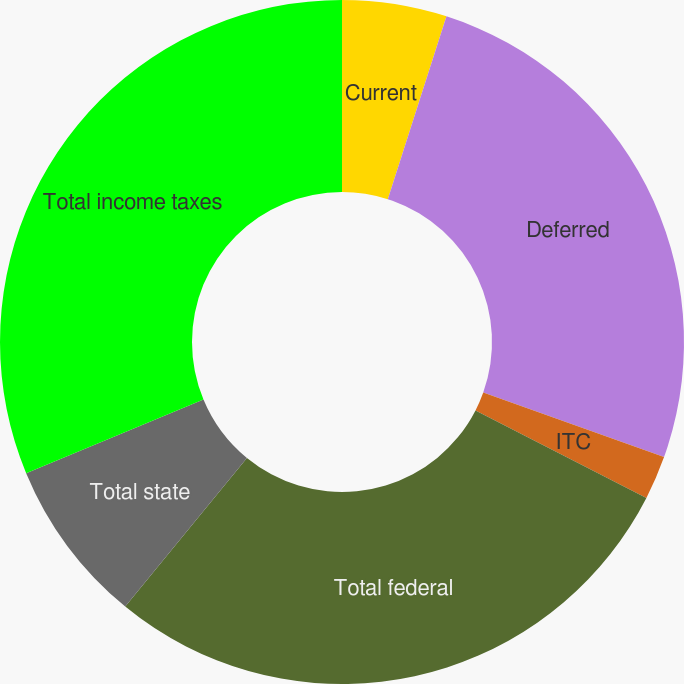Convert chart to OTSL. <chart><loc_0><loc_0><loc_500><loc_500><pie_chart><fcel>Current<fcel>Deferred<fcel>ITC<fcel>Total federal<fcel>Total state<fcel>Total income taxes<nl><fcel>4.94%<fcel>25.52%<fcel>2.07%<fcel>28.39%<fcel>7.81%<fcel>31.26%<nl></chart> 